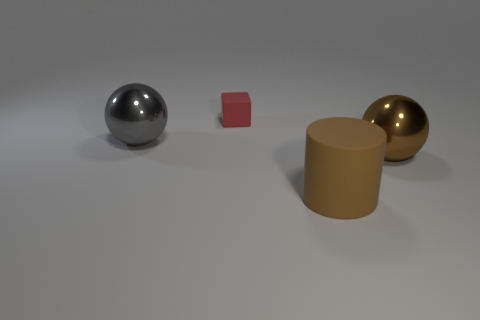Is there any other thing that is the same color as the small matte object? Upon reviewing the image, it appears that none of the other objects share the exact same hue as the small matte red object. 